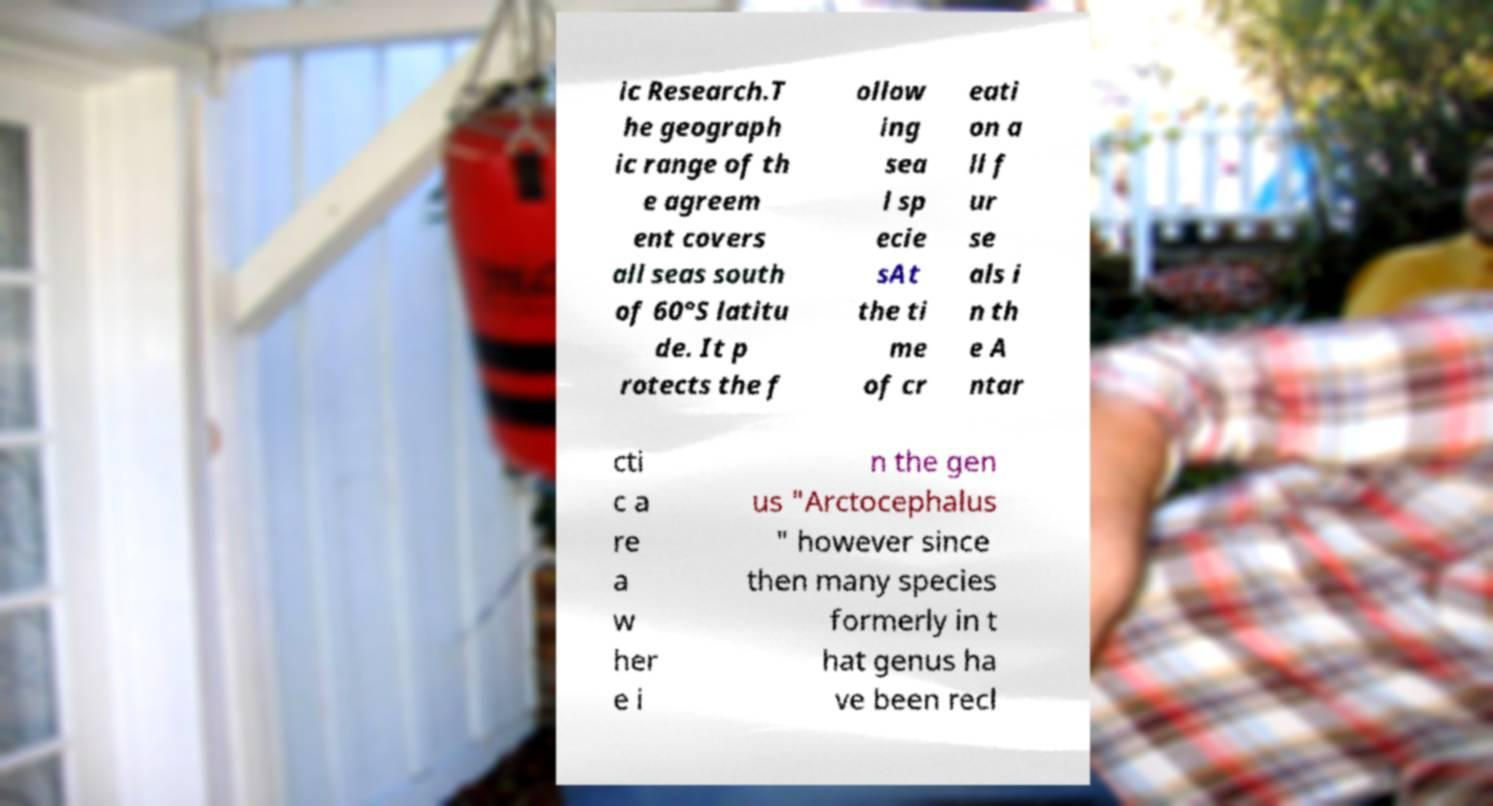Please read and relay the text visible in this image. What does it say? ic Research.T he geograph ic range of th e agreem ent covers all seas south of 60°S latitu de. It p rotects the f ollow ing sea l sp ecie sAt the ti me of cr eati on a ll f ur se als i n th e A ntar cti c a re a w her e i n the gen us "Arctocephalus " however since then many species formerly in t hat genus ha ve been recl 